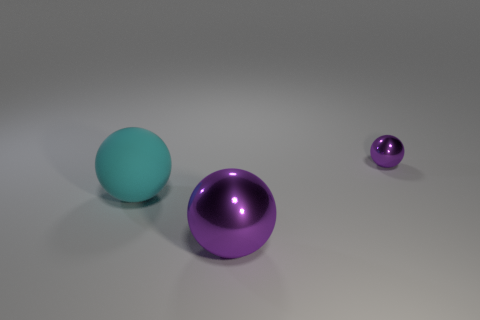Subtract all big spheres. How many spheres are left? 1 Subtract 3 spheres. How many spheres are left? 0 Add 1 purple balls. How many objects exist? 4 Subtract all cyan balls. How many balls are left? 2 Subtract all purple objects. Subtract all small brown shiny cylinders. How many objects are left? 1 Add 1 cyan objects. How many cyan objects are left? 2 Add 2 brown spheres. How many brown spheres exist? 2 Subtract 0 brown cylinders. How many objects are left? 3 Subtract all gray spheres. Subtract all gray cubes. How many spheres are left? 3 Subtract all gray cylinders. How many cyan balls are left? 1 